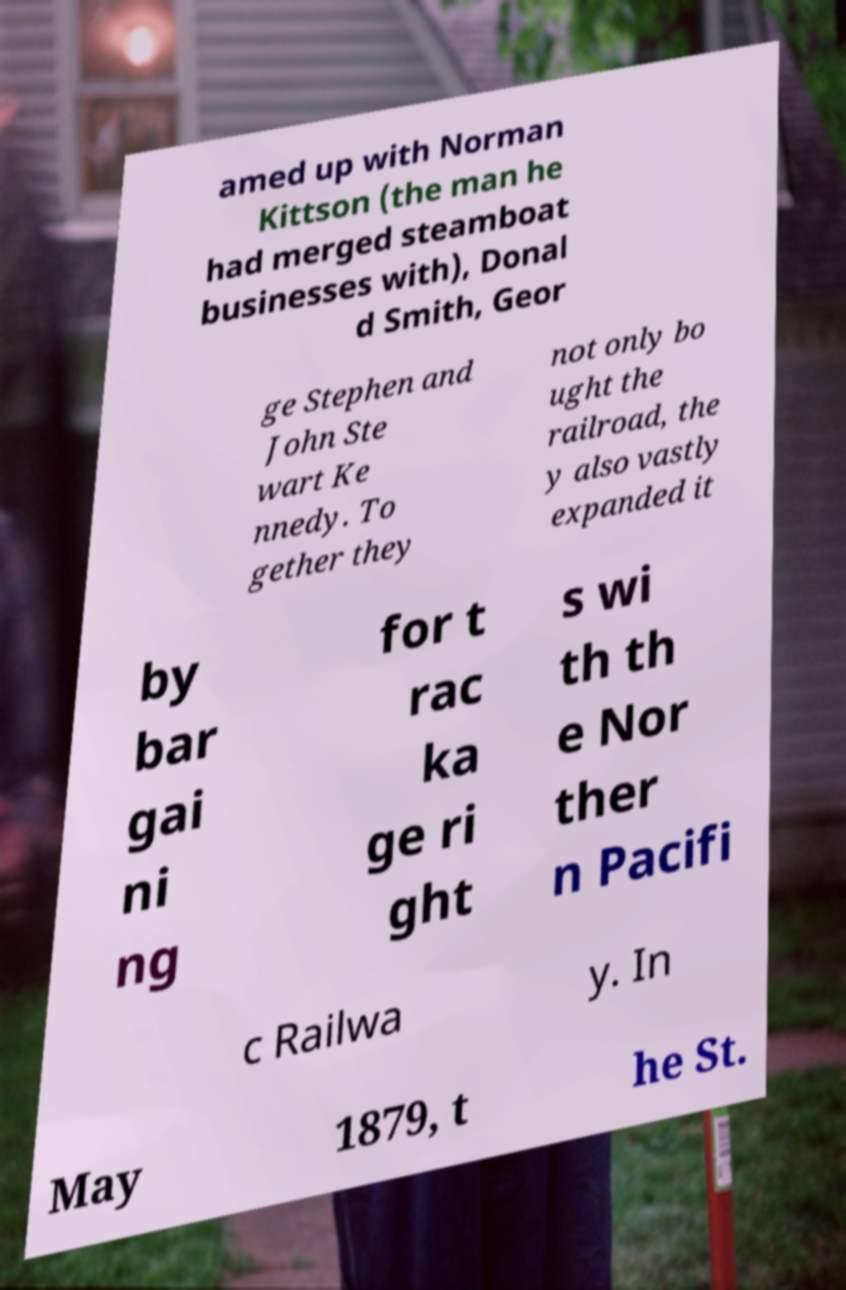I need the written content from this picture converted into text. Can you do that? amed up with Norman Kittson (the man he had merged steamboat businesses with), Donal d Smith, Geor ge Stephen and John Ste wart Ke nnedy. To gether they not only bo ught the railroad, the y also vastly expanded it by bar gai ni ng for t rac ka ge ri ght s wi th th e Nor ther n Pacifi c Railwa y. In May 1879, t he St. 